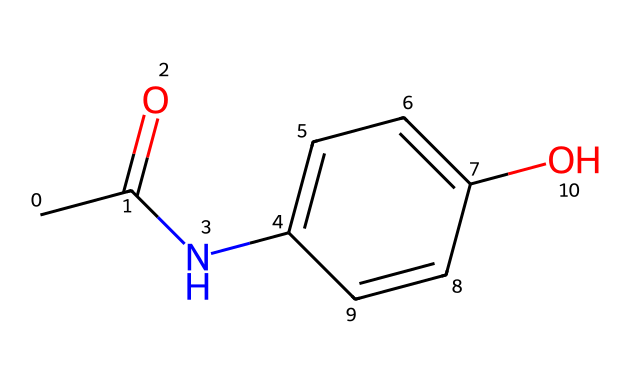How many carbon atoms are present in Paracetamol? By counting the carbon (C) atoms in the SMILES representation, there are a total of 8 carbon atoms in the structure.
Answer: 8 What is the functional group present in Paracetamol? The presence of -OH (hydroxyl) and -NH (amine) groups indicates that the functional groups present are alcohol and amide, respectively.
Answer: alcohol and amide What type of bond connects the carbonyl group to the nitrogen in Paracetamol? The carbonyl (C=O) group is bonded to the nitrogen (N) atom through a single bond, forming an amide linkage.
Answer: single bond What is the molecular formula of Paracetamol? From the SMILES representation, the constituent atoms can be counted, leading to the molecular formula C8H9NO2, which reflects the number of each type of atom present.
Answer: C8H9NO2 How does the presence of the hydroxyl group influence the solubility of Paracetamol? The hydroxyl group (-OH) is polar, which increases the solubility of Paracetamol in water due to hydrogen bonding with water molecules.
Answer: increases solubility Which part of the molecule is primarily responsible for its analgesic properties? The acetamide group (-C(=O)NH-) in the structure is responsible for the analgesic (pain-relieving) effects of Paracetamol.
Answer: acetamide group 